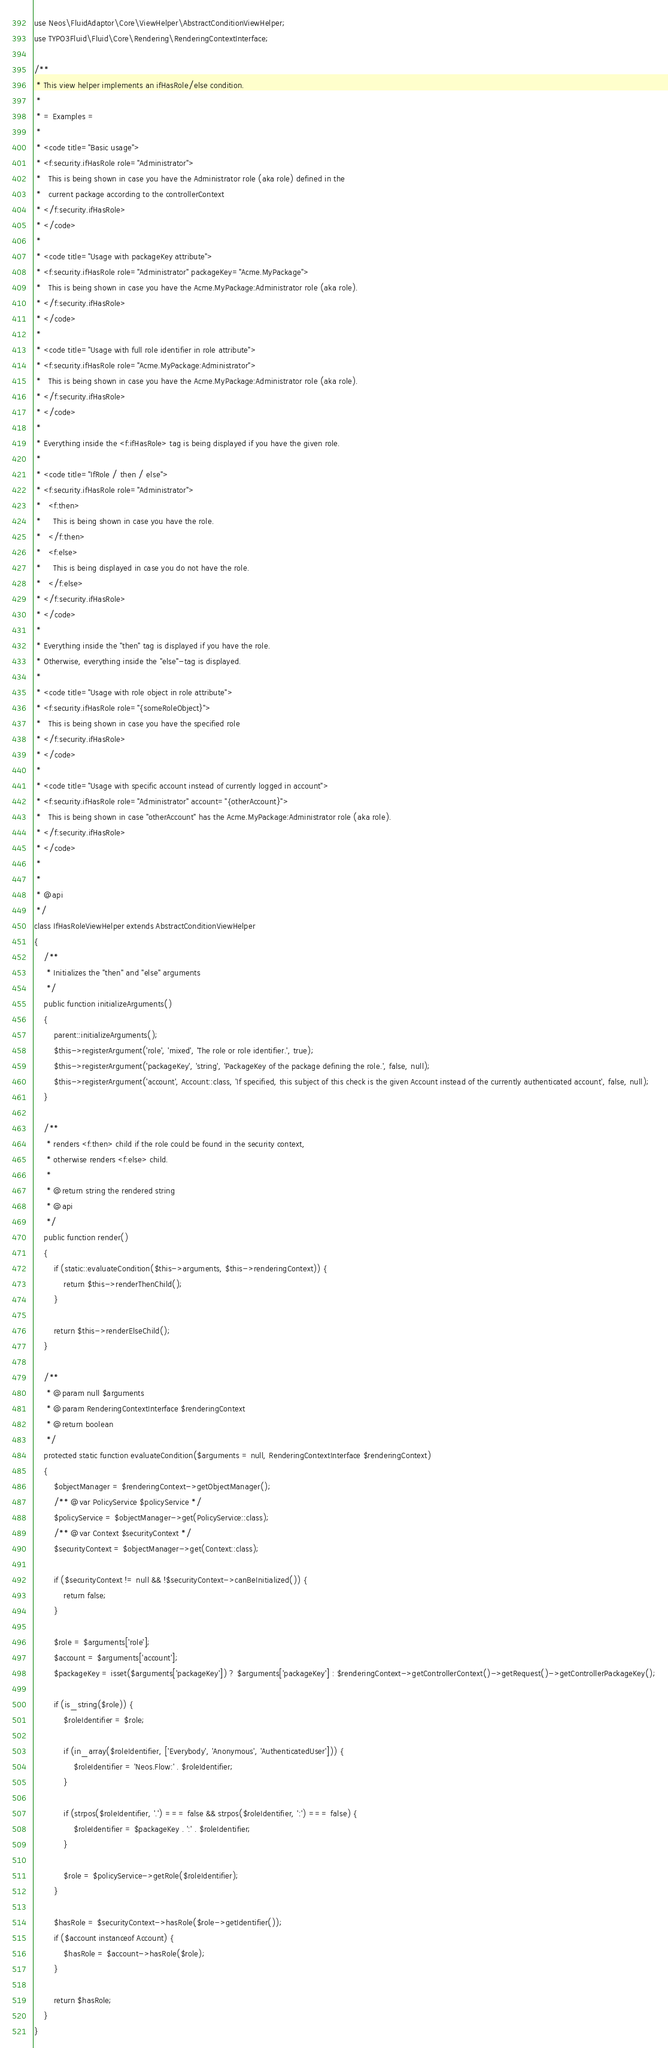<code> <loc_0><loc_0><loc_500><loc_500><_PHP_>use Neos\FluidAdaptor\Core\ViewHelper\AbstractConditionViewHelper;
use TYPO3Fluid\Fluid\Core\Rendering\RenderingContextInterface;

/**
 * This view helper implements an ifHasRole/else condition.
 *
 * = Examples =
 *
 * <code title="Basic usage">
 * <f:security.ifHasRole role="Administrator">
 *   This is being shown in case you have the Administrator role (aka role) defined in the
 *   current package according to the controllerContext
 * </f:security.ifHasRole>
 * </code>
 *
 * <code title="Usage with packageKey attribute">
 * <f:security.ifHasRole role="Administrator" packageKey="Acme.MyPackage">
 *   This is being shown in case you have the Acme.MyPackage:Administrator role (aka role).
 * </f:security.ifHasRole>
 * </code>
 *
 * <code title="Usage with full role identifier in role attribute">
 * <f:security.ifHasRole role="Acme.MyPackage:Administrator">
 *   This is being shown in case you have the Acme.MyPackage:Administrator role (aka role).
 * </f:security.ifHasRole>
 * </code>
 *
 * Everything inside the <f:ifHasRole> tag is being displayed if you have the given role.
 *
 * <code title="IfRole / then / else">
 * <f:security.ifHasRole role="Administrator">
 *   <f:then>
 *     This is being shown in case you have the role.
 *   </f:then>
 *   <f:else>
 *     This is being displayed in case you do not have the role.
 *   </f:else>
 * </f:security.ifHasRole>
 * </code>
 *
 * Everything inside the "then" tag is displayed if you have the role.
 * Otherwise, everything inside the "else"-tag is displayed.
 *
 * <code title="Usage with role object in role attribute">
 * <f:security.ifHasRole role="{someRoleObject}">
 *   This is being shown in case you have the specified role
 * </f:security.ifHasRole>
 * </code>
 *
 * <code title="Usage with specific account instead of currently logged in account">
 * <f:security.ifHasRole role="Administrator" account="{otherAccount}">
 *   This is being shown in case "otherAccount" has the Acme.MyPackage:Administrator role (aka role).
 * </f:security.ifHasRole>
 * </code>
 *
 *
 * @api
 */
class IfHasRoleViewHelper extends AbstractConditionViewHelper
{
    /**
     * Initializes the "then" and "else" arguments
     */
    public function initializeArguments()
    {
        parent::initializeArguments();
        $this->registerArgument('role', 'mixed', 'The role or role identifier.', true);
        $this->registerArgument('packageKey', 'string', 'PackageKey of the package defining the role.', false, null);
        $this->registerArgument('account', Account::class, 'If specified, this subject of this check is the given Account instead of the currently authenticated account', false, null);
    }

    /**
     * renders <f:then> child if the role could be found in the security context,
     * otherwise renders <f:else> child.
     *
     * @return string the rendered string
     * @api
     */
    public function render()
    {
        if (static::evaluateCondition($this->arguments, $this->renderingContext)) {
            return $this->renderThenChild();
        }

        return $this->renderElseChild();
    }

    /**
     * @param null $arguments
     * @param RenderingContextInterface $renderingContext
     * @return boolean
     */
    protected static function evaluateCondition($arguments = null, RenderingContextInterface $renderingContext)
    {
        $objectManager = $renderingContext->getObjectManager();
        /** @var PolicyService $policyService */
        $policyService = $objectManager->get(PolicyService::class);
        /** @var Context $securityContext */
        $securityContext = $objectManager->get(Context::class);

        if ($securityContext != null && !$securityContext->canBeInitialized()) {
            return false;
        }

        $role = $arguments['role'];
        $account = $arguments['account'];
        $packageKey = isset($arguments['packageKey']) ? $arguments['packageKey'] : $renderingContext->getControllerContext()->getRequest()->getControllerPackageKey();

        if (is_string($role)) {
            $roleIdentifier = $role;

            if (in_array($roleIdentifier, ['Everybody', 'Anonymous', 'AuthenticatedUser'])) {
                $roleIdentifier = 'Neos.Flow:' . $roleIdentifier;
            }

            if (strpos($roleIdentifier, '.') === false && strpos($roleIdentifier, ':') === false) {
                $roleIdentifier = $packageKey . ':' . $roleIdentifier;
            }

            $role = $policyService->getRole($roleIdentifier);
        }

        $hasRole = $securityContext->hasRole($role->getIdentifier());
        if ($account instanceof Account) {
            $hasRole = $account->hasRole($role);
        }

        return $hasRole;
    }
}
</code> 